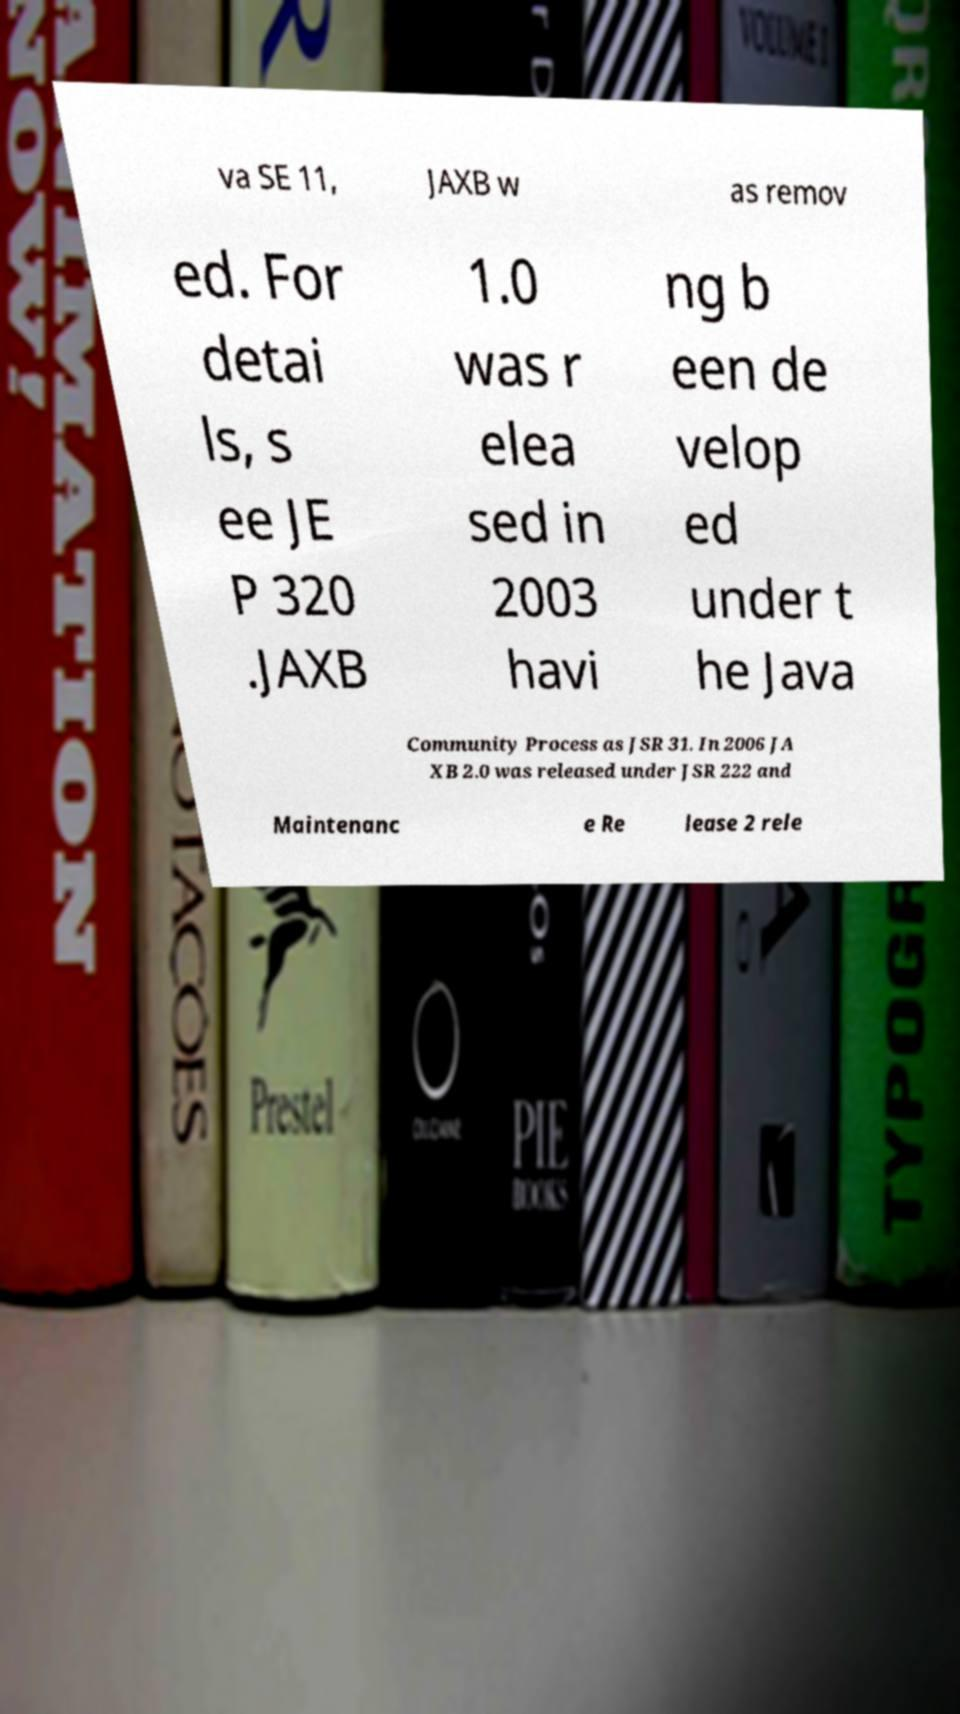Please read and relay the text visible in this image. What does it say? va SE 11, JAXB w as remov ed. For detai ls, s ee JE P 320 .JAXB 1.0 was r elea sed in 2003 havi ng b een de velop ed under t he Java Community Process as JSR 31. In 2006 JA XB 2.0 was released under JSR 222 and Maintenanc e Re lease 2 rele 